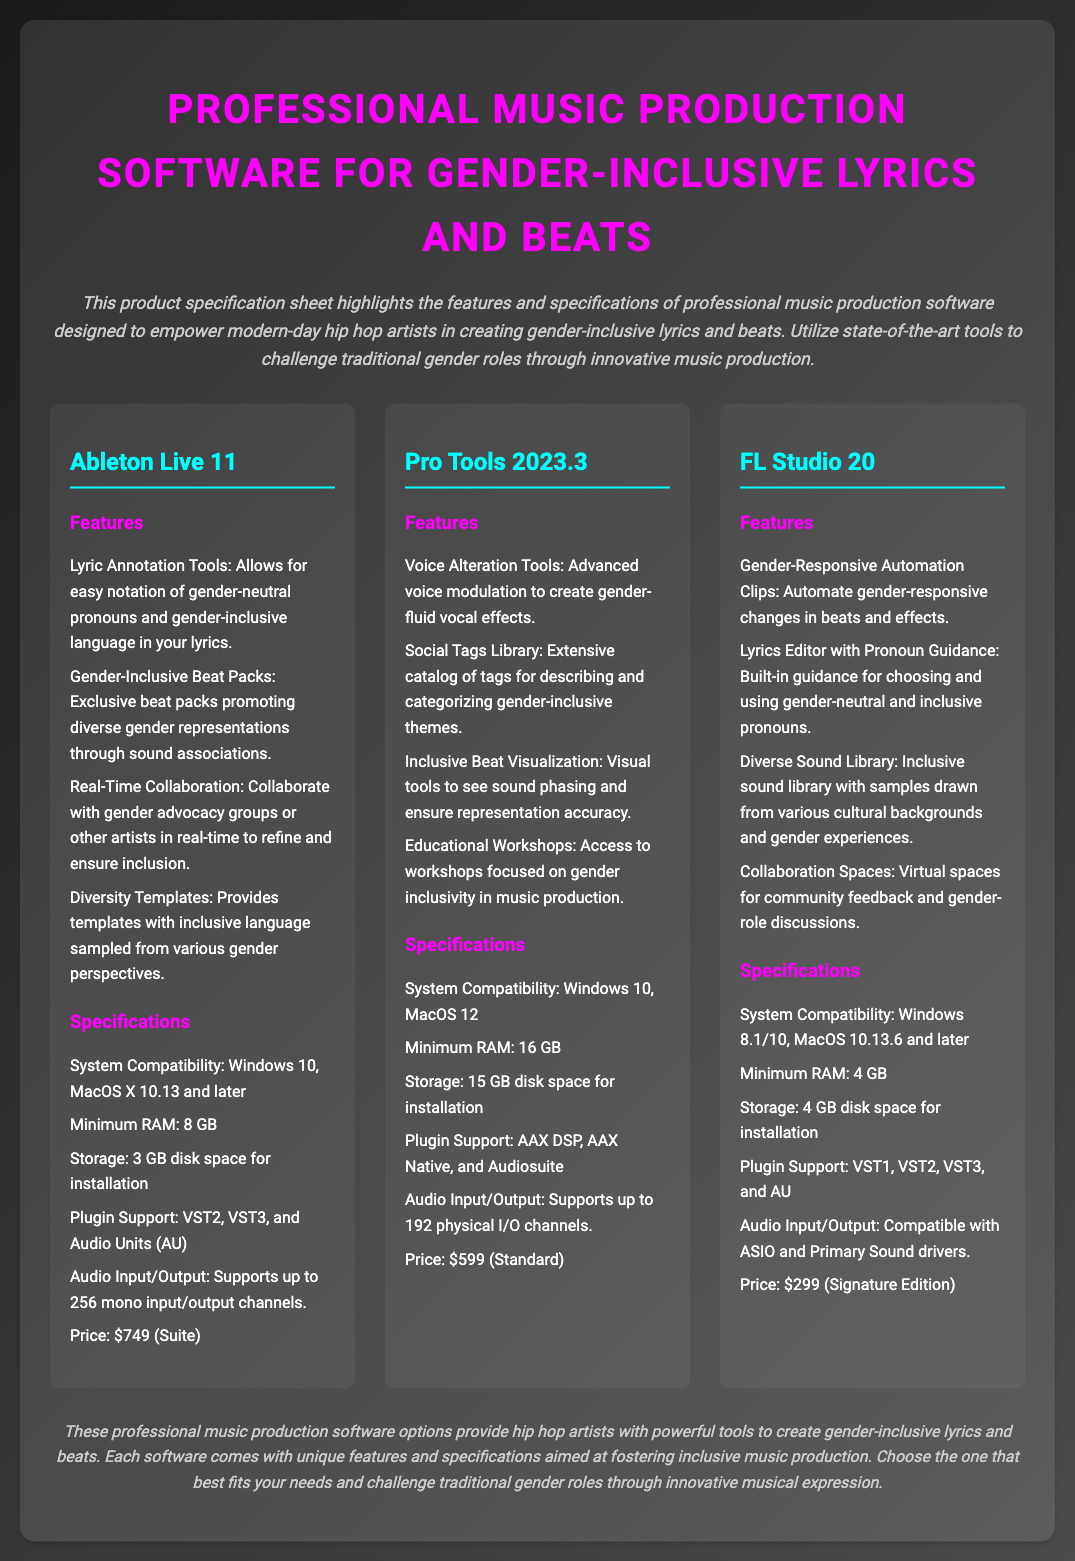what is the title of the document? The title is prominently displayed at the top of the document, which is "Professional Music Production Software for Gender-Inclusive Lyrics and Beats."
Answer: Professional Music Production Software for Gender-Inclusive Lyrics and Beats how many software options are listed? The document details three different software options for music production.
Answer: 3 what is the price of Ableton Live 11? The pricing information for Ableton Live 11 is clearly stated as $749 under the specifications section.
Answer: $749 which software offers real-time collaboration? The features of Ableton Live 11 mention a tool for real-time collaboration in music production.
Answer: Ableton Live 11 what is the minimum RAM required for Pro Tools 2023.3? The specifications for Pro Tools state that the minimum RAM requirement is 16 GB.
Answer: 16 GB what unique feature does FL Studio 20 have? The unique feature mentioned for FL Studio 20 is gender-responsive automation clips.
Answer: Gender-Responsive Automation Clips which software has a 'Social Tags Library'? The document states that Pro Tools 2023.3 includes a Social Tags Library for categorizing gender-inclusive themes.
Answer: Pro Tools 2023.3 how many audio I/O channels does Ableton Live 11 support? The specifications indicate that Ableton Live 11 supports up to 256 mono input/output channels.
Answer: 256 mono input/output channels what type of templates does Ableton Live 11 provide? The document notes that Ableton Live 11 offers diversity templates with inclusive language.
Answer: Diversity Templates 